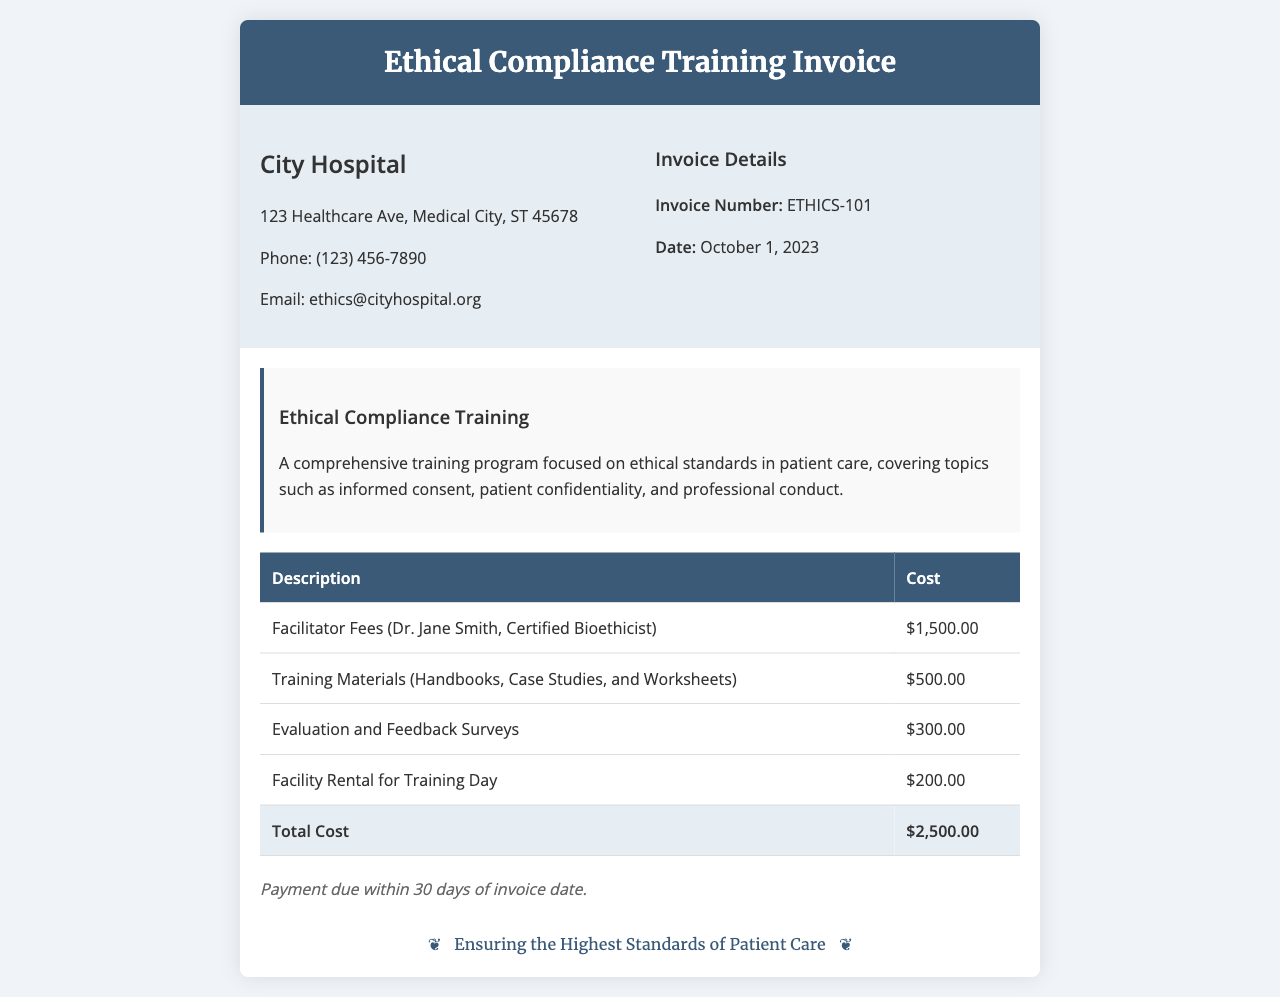What is the invoice number? The invoice number is located in the invoice details section of the document.
Answer: ETHICS-101 Who is the facilitator for the training? The facilitator's name is mentioned in the cost breakdown section.
Answer: Dr. Jane Smith What is the total cost of the training? The total cost is listed in the table as the last entry.
Answer: $2,500.00 When is the payment due? The payment terms specify the timeline for payment.
Answer: 30 days What is included in the training materials cost? The training materials are detailed in the cost breakdown section.
Answer: Handbooks, Case Studies, and Worksheets How much was spent on facility rental? The facility rental cost is mentioned in the table.
Answer: $200.00 What are the topics covered in the training program? The topics are described in the training program overview.
Answer: Informed consent, patient confidentiality, and professional conduct What is the date of the invoice? The date is indicated in the invoice details section.
Answer: October 1, 2023 What is the hospital's email address? The hospital's contact information includes the email address.
Answer: ethics@cityhospital.org 